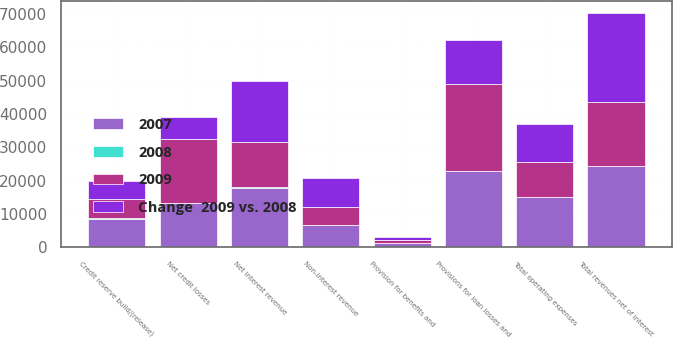Convert chart. <chart><loc_0><loc_0><loc_500><loc_500><stacked_bar_chart><ecel><fcel>Net interest revenue<fcel>Non-interest revenue<fcel>Total revenues net of interest<fcel>Total operating expenses<fcel>Net credit losses<fcel>Credit reserve build/(release)<fcel>Provision for benefits and<fcel>Provisions for loan losses and<nl><fcel>2009<fcel>13709<fcel>5473<fcel>19182<fcel>10431<fcel>19237<fcel>5904<fcel>1055<fcel>26199<nl><fcel>2007<fcel>17903<fcel>6550<fcel>24453<fcel>14973<fcel>13151<fcel>8592<fcel>1191<fcel>22934<nl><fcel>Change  2009 vs. 2008<fcel>18166<fcel>8584<fcel>26750<fcel>11457<fcel>6794<fcel>5454<fcel>765<fcel>13013<nl><fcel>2008<fcel>23<fcel>16<fcel>22<fcel>30<fcel>46<fcel>31<fcel>11<fcel>14<nl></chart> 